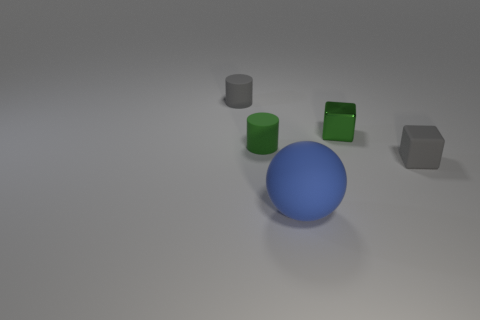Subtract all cyan blocks. Subtract all red balls. How many blocks are left? 2 Add 5 big red metal cylinders. How many objects exist? 10 Subtract all cylinders. How many objects are left? 3 Subtract all large balls. Subtract all small cubes. How many objects are left? 2 Add 5 tiny green metallic objects. How many tiny green metallic objects are left? 6 Add 2 gray things. How many gray things exist? 4 Subtract 0 brown cylinders. How many objects are left? 5 